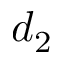Convert formula to latex. <formula><loc_0><loc_0><loc_500><loc_500>d _ { 2 }</formula> 